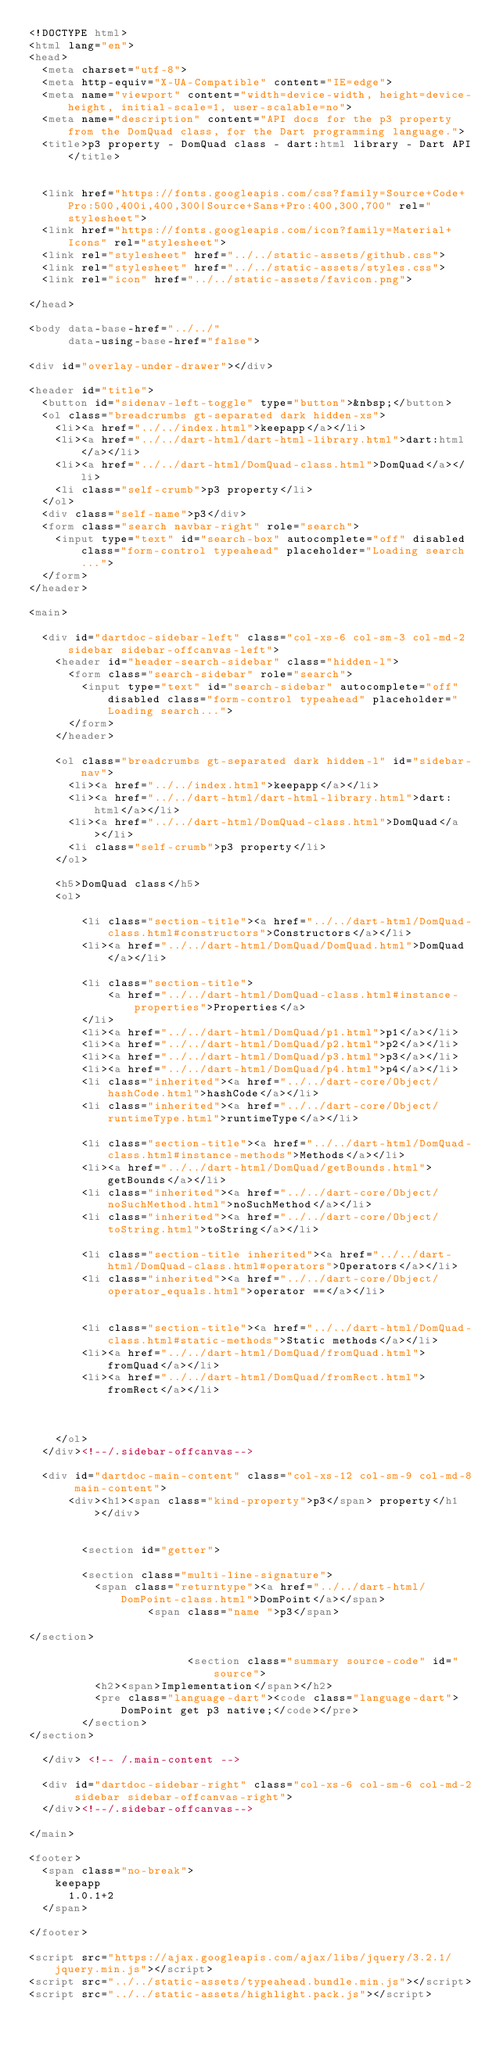<code> <loc_0><loc_0><loc_500><loc_500><_HTML_><!DOCTYPE html>
<html lang="en">
<head>
  <meta charset="utf-8">
  <meta http-equiv="X-UA-Compatible" content="IE=edge">
  <meta name="viewport" content="width=device-width, height=device-height, initial-scale=1, user-scalable=no">
  <meta name="description" content="API docs for the p3 property from the DomQuad class, for the Dart programming language.">
  <title>p3 property - DomQuad class - dart:html library - Dart API</title>

  
  <link href="https://fonts.googleapis.com/css?family=Source+Code+Pro:500,400i,400,300|Source+Sans+Pro:400,300,700" rel="stylesheet">
  <link href="https://fonts.googleapis.com/icon?family=Material+Icons" rel="stylesheet">
  <link rel="stylesheet" href="../../static-assets/github.css">
  <link rel="stylesheet" href="../../static-assets/styles.css">
  <link rel="icon" href="../../static-assets/favicon.png">

</head>

<body data-base-href="../../"
      data-using-base-href="false">

<div id="overlay-under-drawer"></div>

<header id="title">
  <button id="sidenav-left-toggle" type="button">&nbsp;</button>
  <ol class="breadcrumbs gt-separated dark hidden-xs">
    <li><a href="../../index.html">keepapp</a></li>
    <li><a href="../../dart-html/dart-html-library.html">dart:html</a></li>
    <li><a href="../../dart-html/DomQuad-class.html">DomQuad</a></li>
    <li class="self-crumb">p3 property</li>
  </ol>
  <div class="self-name">p3</div>
  <form class="search navbar-right" role="search">
    <input type="text" id="search-box" autocomplete="off" disabled class="form-control typeahead" placeholder="Loading search...">
  </form>
</header>

<main>

  <div id="dartdoc-sidebar-left" class="col-xs-6 col-sm-3 col-md-2 sidebar sidebar-offcanvas-left">
    <header id="header-search-sidebar" class="hidden-l">
      <form class="search-sidebar" role="search">
        <input type="text" id="search-sidebar" autocomplete="off" disabled class="form-control typeahead" placeholder="Loading search...">
      </form>
    </header>
    
    <ol class="breadcrumbs gt-separated dark hidden-l" id="sidebar-nav">
      <li><a href="../../index.html">keepapp</a></li>
      <li><a href="../../dart-html/dart-html-library.html">dart:html</a></li>
      <li><a href="../../dart-html/DomQuad-class.html">DomQuad</a></li>
      <li class="self-crumb">p3 property</li>
    </ol>
    
    <h5>DomQuad class</h5>
    <ol>
    
        <li class="section-title"><a href="../../dart-html/DomQuad-class.html#constructors">Constructors</a></li>
        <li><a href="../../dart-html/DomQuad/DomQuad.html">DomQuad</a></li>
    
        <li class="section-title">
            <a href="../../dart-html/DomQuad-class.html#instance-properties">Properties</a>
        </li>
        <li><a href="../../dart-html/DomQuad/p1.html">p1</a></li>
        <li><a href="../../dart-html/DomQuad/p2.html">p2</a></li>
        <li><a href="../../dart-html/DomQuad/p3.html">p3</a></li>
        <li><a href="../../dart-html/DomQuad/p4.html">p4</a></li>
        <li class="inherited"><a href="../../dart-core/Object/hashCode.html">hashCode</a></li>
        <li class="inherited"><a href="../../dart-core/Object/runtimeType.html">runtimeType</a></li>
    
        <li class="section-title"><a href="../../dart-html/DomQuad-class.html#instance-methods">Methods</a></li>
        <li><a href="../../dart-html/DomQuad/getBounds.html">getBounds</a></li>
        <li class="inherited"><a href="../../dart-core/Object/noSuchMethod.html">noSuchMethod</a></li>
        <li class="inherited"><a href="../../dart-core/Object/toString.html">toString</a></li>
    
        <li class="section-title inherited"><a href="../../dart-html/DomQuad-class.html#operators">Operators</a></li>
        <li class="inherited"><a href="../../dart-core/Object/operator_equals.html">operator ==</a></li>
    
    
        <li class="section-title"><a href="../../dart-html/DomQuad-class.html#static-methods">Static methods</a></li>
        <li><a href="../../dart-html/DomQuad/fromQuad.html">fromQuad</a></li>
        <li><a href="../../dart-html/DomQuad/fromRect.html">fromRect</a></li>
    
    
    
    </ol>
  </div><!--/.sidebar-offcanvas-->

  <div id="dartdoc-main-content" class="col-xs-12 col-sm-9 col-md-8 main-content">
      <div><h1><span class="kind-property">p3</span> property</h1></div>


        <section id="getter">
        
        <section class="multi-line-signature">
          <span class="returntype"><a href="../../dart-html/DomPoint-class.html">DomPoint</a></span>
                  <span class="name ">p3</span>
          
</section>
        
                        <section class="summary source-code" id="source">
          <h2><span>Implementation</span></h2>
          <pre class="language-dart"><code class="language-dart">DomPoint get p3 native;</code></pre>
        </section>
</section>
        
  </div> <!-- /.main-content -->

  <div id="dartdoc-sidebar-right" class="col-xs-6 col-sm-6 col-md-2 sidebar sidebar-offcanvas-right">
  </div><!--/.sidebar-offcanvas-->

</main>

<footer>
  <span class="no-break">
    keepapp
      1.0.1+2
  </span>

</footer>

<script src="https://ajax.googleapis.com/ajax/libs/jquery/3.2.1/jquery.min.js"></script>
<script src="../../static-assets/typeahead.bundle.min.js"></script>
<script src="../../static-assets/highlight.pack.js"></script></code> 